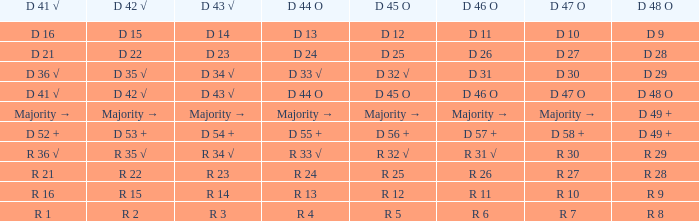What is the d45o with a predominantly d44o composition? Majority →. Can you give me this table as a dict? {'header': ['D 41 √', 'D 42 √', 'D 43 √', 'D 44 O', 'D 45 O', 'D 46 O', 'D 47 O', 'D 48 O'], 'rows': [['D 16', 'D 15', 'D 14', 'D 13', 'D 12', 'D 11', 'D 10', 'D 9'], ['D 21', 'D 22', 'D 23', 'D 24', 'D 25', 'D 26', 'D 27', 'D 28'], ['D 36 √', 'D 35 √', 'D 34 √', 'D 33 √', 'D 32 √', 'D 31', 'D 30', 'D 29'], ['D 41 √', 'D 42 √', 'D 43 √', 'D 44 O', 'D 45 O', 'D 46 O', 'D 47 O', 'D 48 O'], ['Majority →', 'Majority →', 'Majority →', 'Majority →', 'Majority →', 'Majority →', 'Majority →', 'D 49 +'], ['D 52 +', 'D 53 +', 'D 54 +', 'D 55 +', 'D 56 +', 'D 57 +', 'D 58 +', 'D 49 +'], ['R 36 √', 'R 35 √', 'R 34 √', 'R 33 √', 'R 32 √', 'R 31 √', 'R 30', 'R 29'], ['R 21', 'R 22', 'R 23', 'R 24', 'R 25', 'R 26', 'R 27', 'R 28'], ['R 16', 'R 15', 'R 14', 'R 13', 'R 12', 'R 11', 'R 10', 'R 9'], ['R 1', 'R 2', 'R 3', 'R 4', 'R 5', 'R 6', 'R 7', 'R 8']]} 